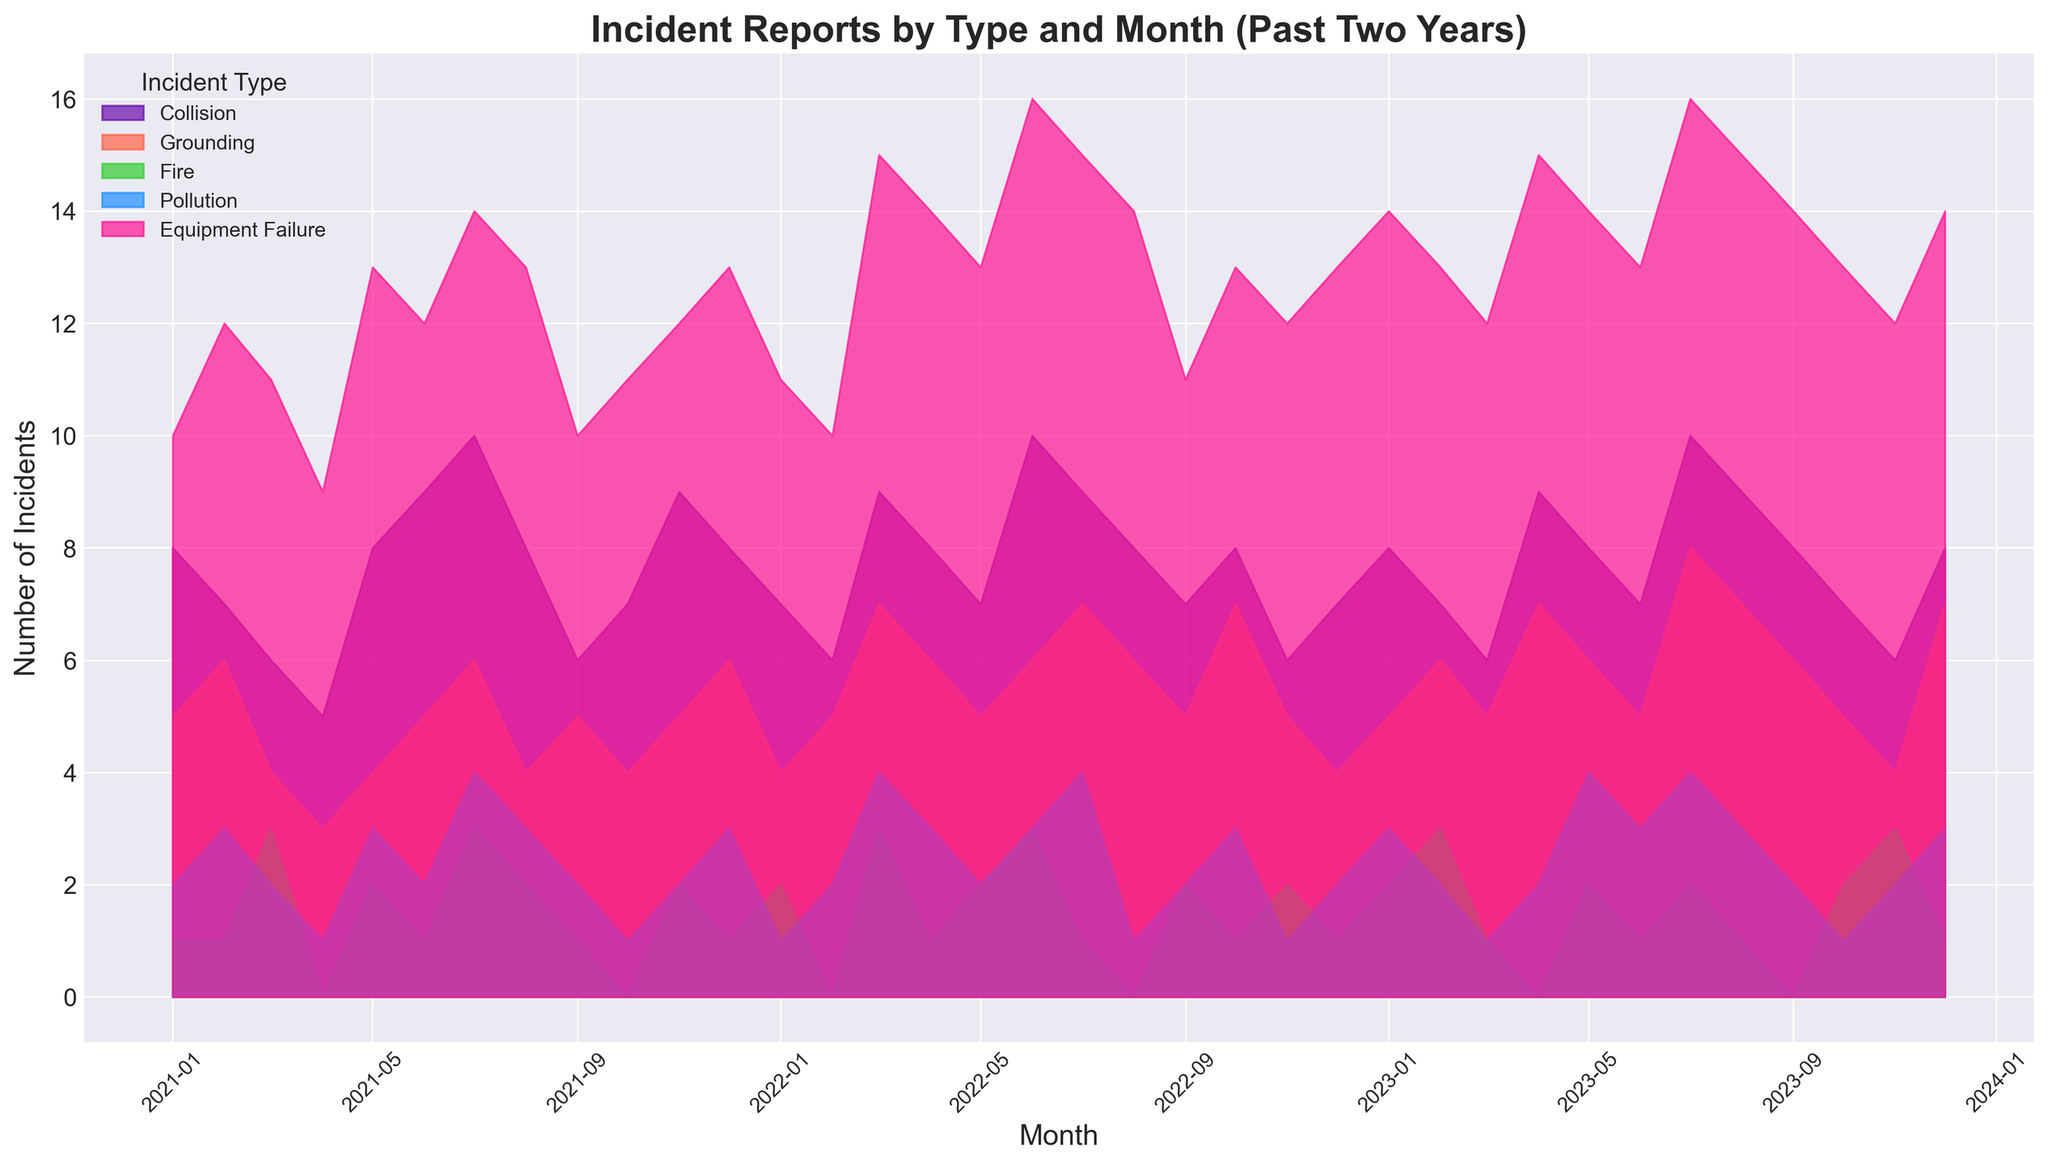What is the highest number of Collision incidents reported in any month? The highest point on the Collision area plot shows the maximum number of Collision incidents. It reaches 10 incidents in July 2021 and July 2023.
Answer: 10 Which incident type consistently has higher counts, Grounding or Fire? By observing the height of the areas for Grounding and Fire incidents across the time series, Grounding consistently shows higher counts than Fire in almost every month.
Answer: Grounding How many total incidents were reported in December 2022? To find the total number of incidents, sum the incidents of all types for December 2022. The categories and their counts are Collision: 7, Grounding: 4, Fire: 1, Pollution: 2, and Equipment Failure: 13. Summing these gives 7 + 4 + 1 + 2 + 13 = 27.
Answer: 27 Which month in 2023 saw the highest number of Fire incidents? By examining the Fire incidents area plot, March 2023 and November 2023 show the highest number of Fire incidents, each recording 3 incidents.
Answer: March and November During which month did Equipment Failure incidents peak, and what was that peak value? The highest point in the Equipment Failure area plot indicates the peak value, which occurs in June 2022 and July 2023, both showing 16 incidents.
Answer: June 2022 and July 2023, 16 Compare the total number of incidents in January 2021 with January 2023. Which year had fewer incidents? Sum the incidents for all categories in January 2021 (Collision: 8, Grounding: 5, Fire: 1, Pollution: 2, Equipment Failure: 10) giving 8 + 5 + 1 + 2 + 10 = 26. For January 2023 (Collision: 8, Grounding: 5, Fire: 2, Pollution: 3, Equipment Failure: 14) giving 8 + 5 + 2 + 3 + 14 = 32. Therefore, January 2021 had fewer incidents.
Answer: January 2021 What is the average number of Pollution incidents per month over the past two years? Since there are 24 months of data, sum the Pollution incidents for each month and divide by 24. The total number of Pollution incidents is 2+3+2+1+3+2+4+3+2+1+2+3+1+2+4+3+2+3+4+1+3+2+1+2=52. Dividing 52 by 24 gives approximately 2.17.
Answer: 2.17 Which incident type shows the most noticeable upward or downward trend over the past two years? By looking at the overall shapes of the area plots, Equipment Failure shows a noticeable upward trend, indicated by increasing area sizes over time.
Answer: Equipment Failure 